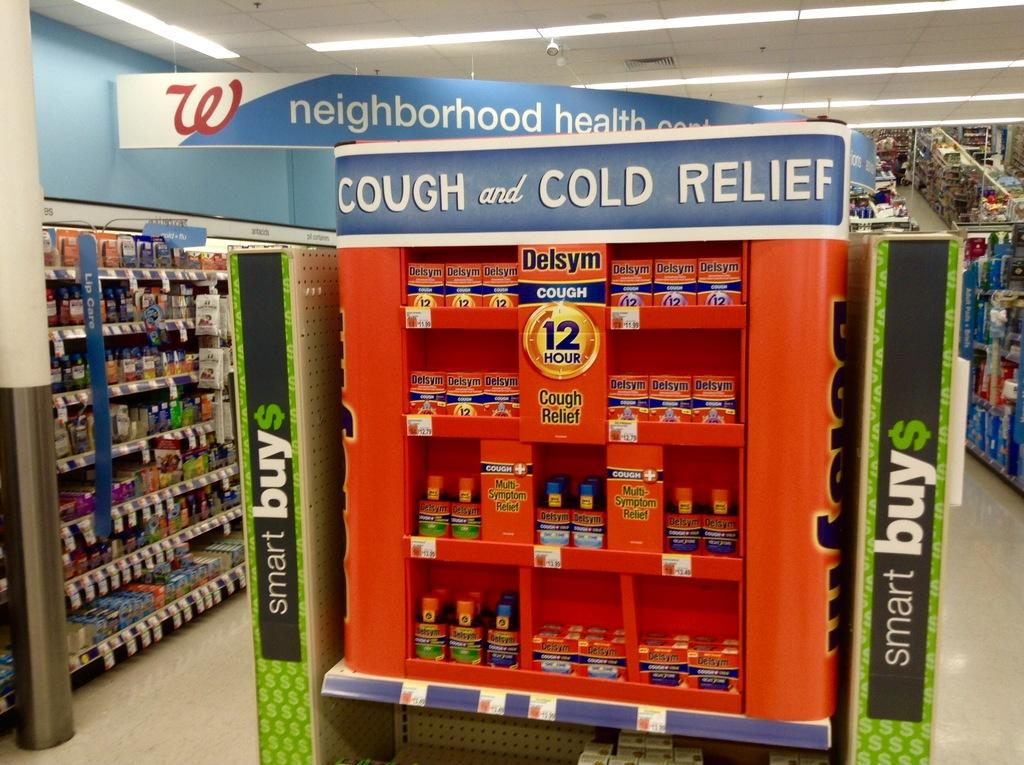What type of structure can be seen in the image? There are aisles in the image. What are the aisles used for in the image? The aisles are used for displaying products in the supermarket. What else can be seen in the image besides the aisles? There are display boards in the image. Can you describe the setting of the image? The setting is a supermarket. What type of hand soap is being advertised on the display board in the image? There is no hand soap or display board advertising hand soap present in the image. 